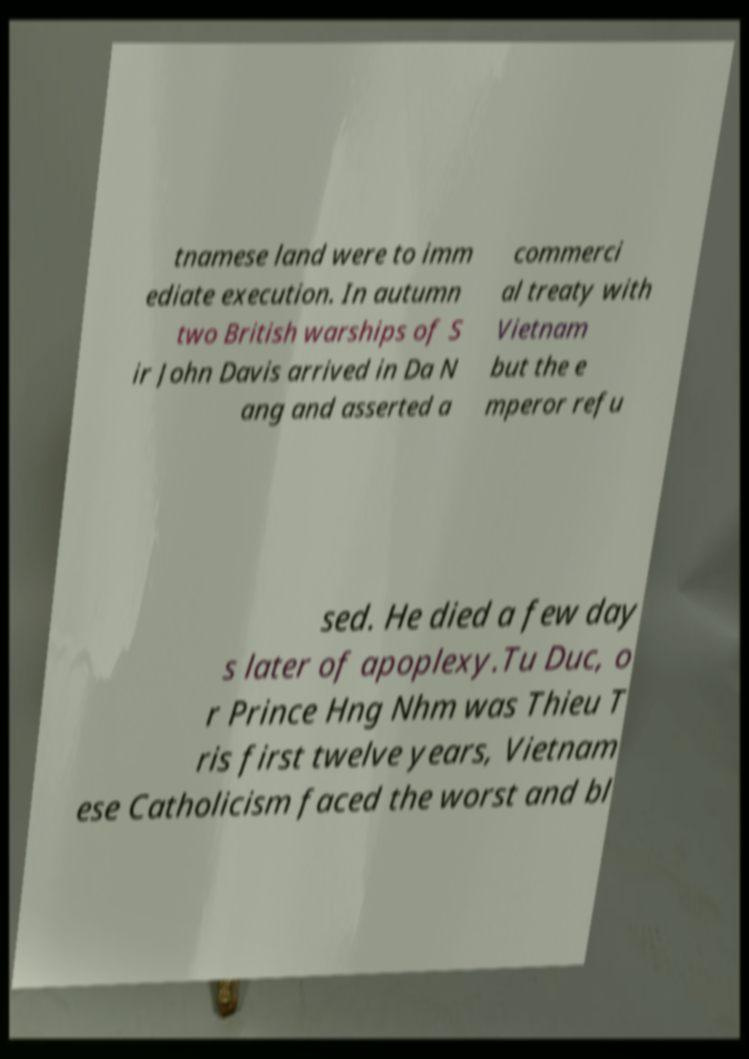For documentation purposes, I need the text within this image transcribed. Could you provide that? tnamese land were to imm ediate execution. In autumn two British warships of S ir John Davis arrived in Da N ang and asserted a commerci al treaty with Vietnam but the e mperor refu sed. He died a few day s later of apoplexy.Tu Duc, o r Prince Hng Nhm was Thieu T ris first twelve years, Vietnam ese Catholicism faced the worst and bl 